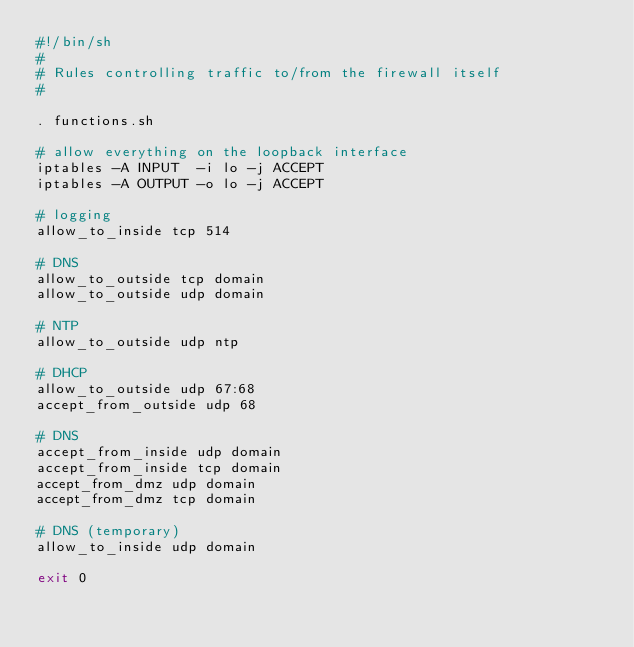Convert code to text. <code><loc_0><loc_0><loc_500><loc_500><_Bash_>#!/bin/sh
#
# Rules controlling traffic to/from the firewall itself 
#

. functions.sh

# allow everything on the loopback interface
iptables -A INPUT  -i lo -j ACCEPT
iptables -A OUTPUT -o lo -j ACCEPT

# logging
allow_to_inside tcp 514

# DNS
allow_to_outside tcp domain
allow_to_outside udp domain

# NTP
allow_to_outside udp ntp

# DHCP
allow_to_outside udp 67:68
accept_from_outside udp 68

# DNS
accept_from_inside udp domain
accept_from_inside tcp domain
accept_from_dmz udp domain
accept_from_dmz tcp domain

# DNS (temporary)
allow_to_inside udp domain

exit 0

</code> 